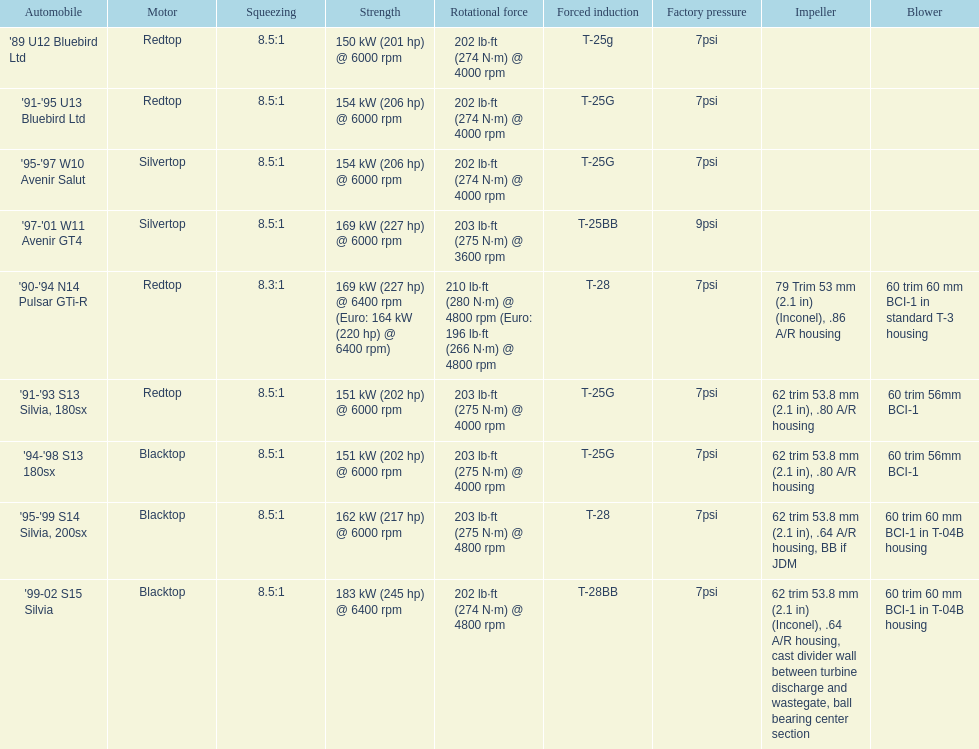Which engine(s) has the least amount of power? Redtop. 